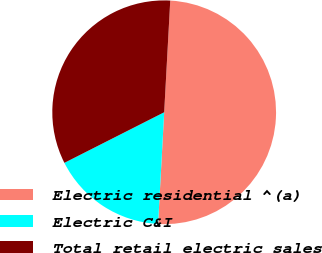Convert chart to OTSL. <chart><loc_0><loc_0><loc_500><loc_500><pie_chart><fcel>Electric residential ^(a)<fcel>Electric C&I<fcel>Total retail electric sales<nl><fcel>50.0%<fcel>16.67%<fcel>33.33%<nl></chart> 